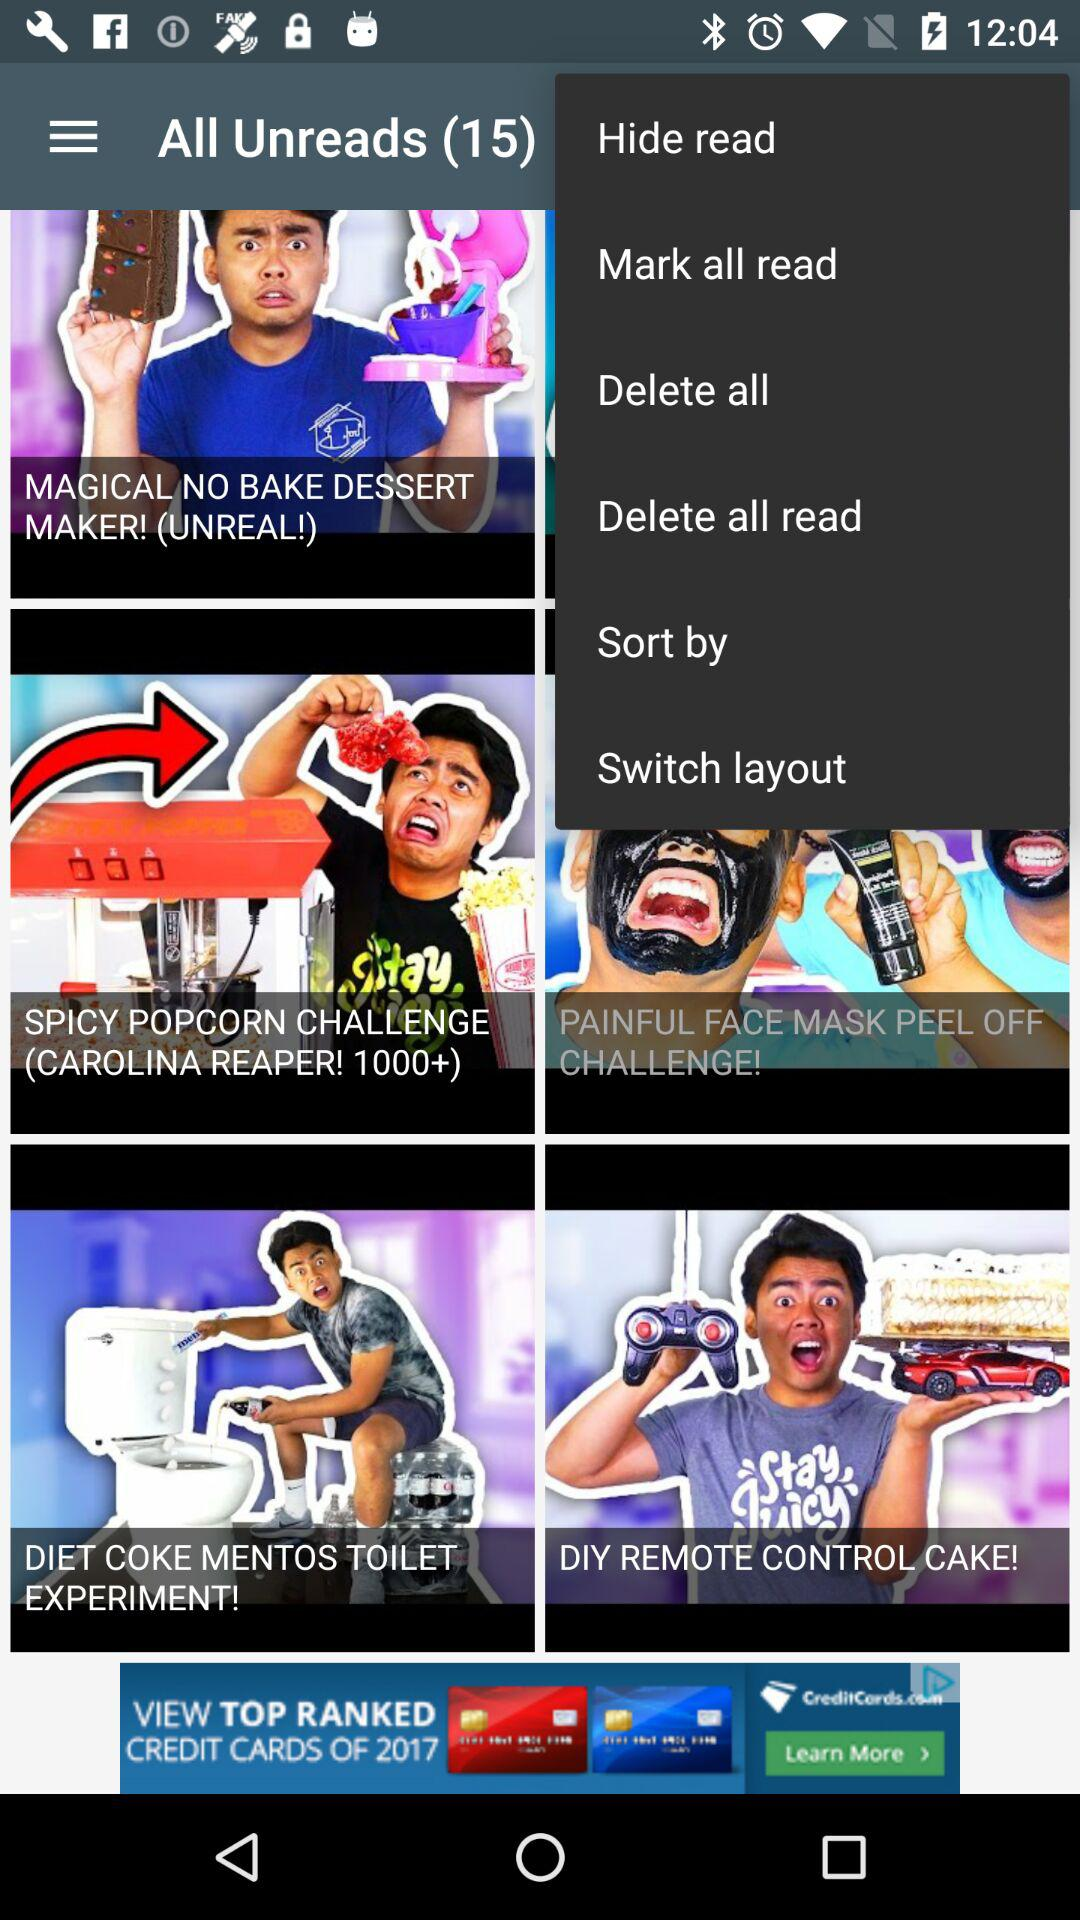How many unread messages are there? There are 15 unread messages. 